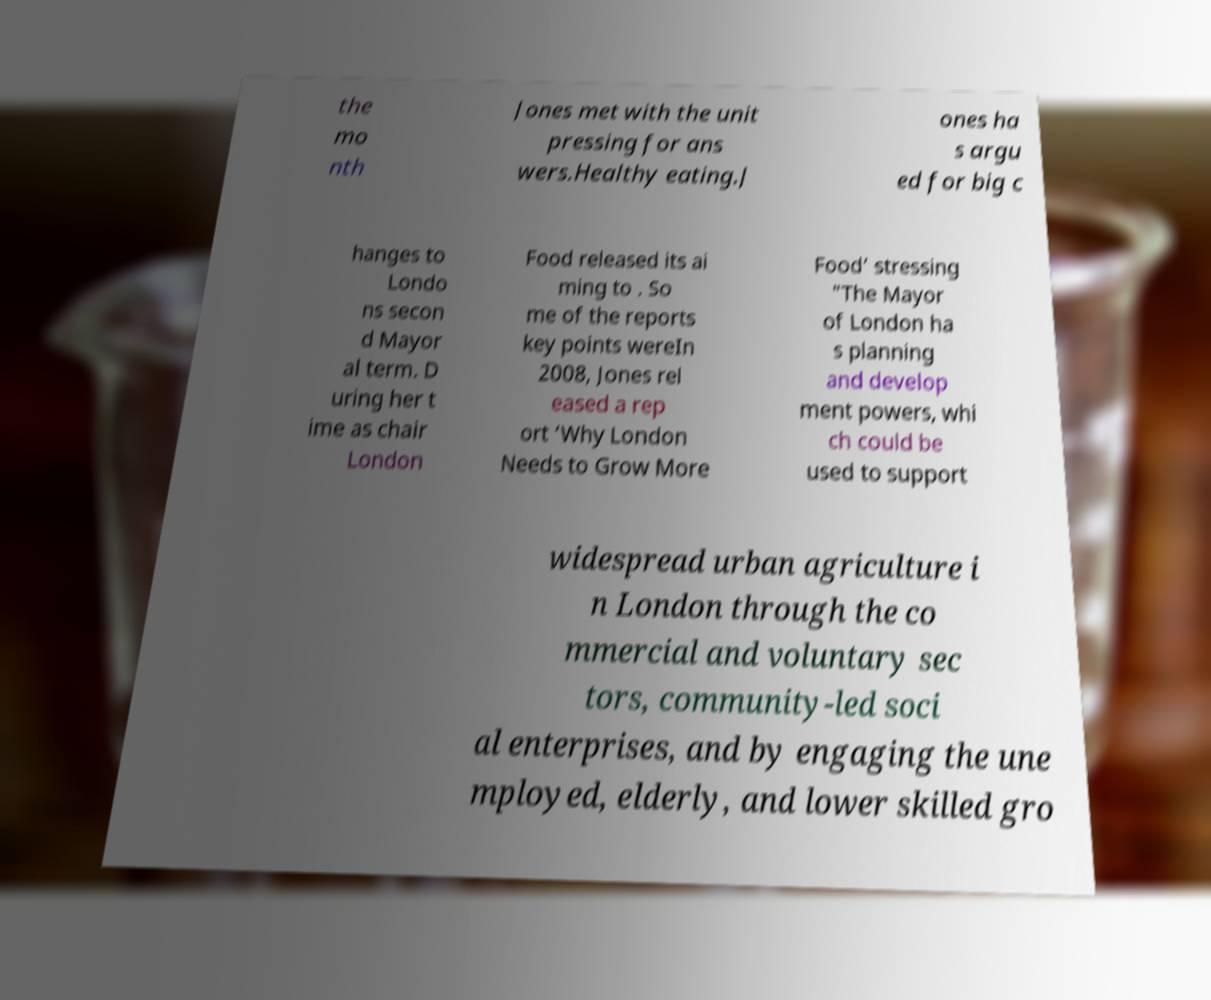Could you assist in decoding the text presented in this image and type it out clearly? the mo nth Jones met with the unit pressing for ans wers.Healthy eating.J ones ha s argu ed for big c hanges to Londo ns secon d Mayor al term. D uring her t ime as chair London Food released its ai ming to . So me of the reports key points wereIn 2008, Jones rel eased a rep ort ‘Why London Needs to Grow More Food’ stressing "The Mayor of London ha s planning and develop ment powers, whi ch could be used to support widespread urban agriculture i n London through the co mmercial and voluntary sec tors, community-led soci al enterprises, and by engaging the une mployed, elderly, and lower skilled gro 